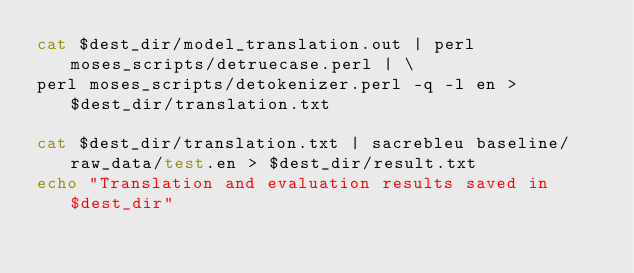<code> <loc_0><loc_0><loc_500><loc_500><_Bash_>cat $dest_dir/model_translation.out | perl moses_scripts/detruecase.perl | \
perl moses_scripts/detokenizer.perl -q -l en > $dest_dir/translation.txt

cat $dest_dir/translation.txt | sacrebleu baseline/raw_data/test.en > $dest_dir/result.txt
echo "Translation and evaluation results saved in $dest_dir"
</code> 